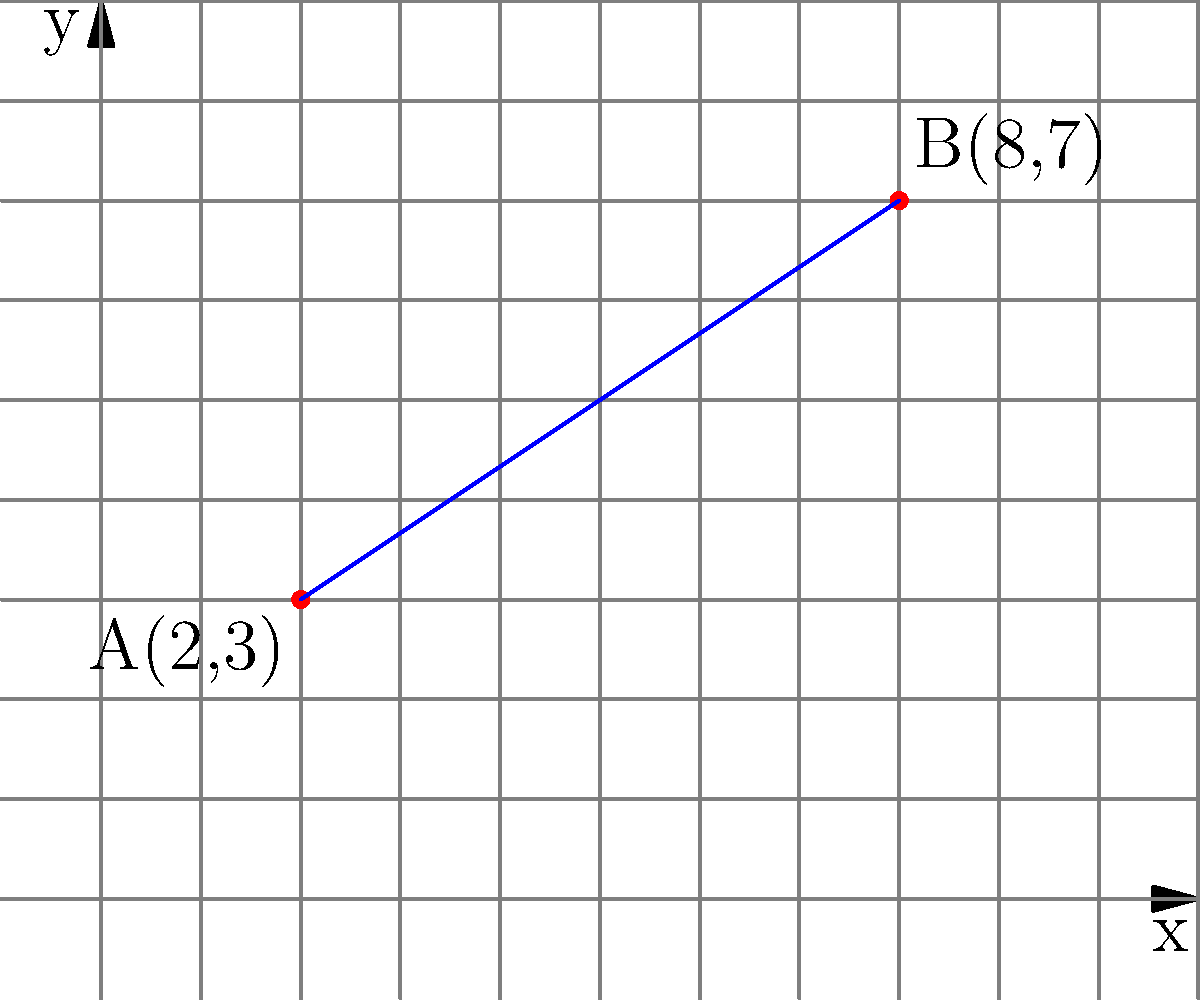No gráfico acima, temos dois pontos A(2,3) e B(8,7) conectados por uma linha reta. Calcule a inclinação (coeficiente angular) desta linha usando a fórmula da inclinação. Apresente sua resposta como uma fração simplificada. Para calcular a inclinação de uma linha reta entre dois pontos, usamos a fórmula:

$$ m = \frac{y_2 - y_1}{x_2 - x_1} $$

Onde $(x_1, y_1)$ são as coordenadas do primeiro ponto e $(x_2, y_2)$ são as coordenadas do segundo ponto.

Neste caso, temos:
A(2,3) como $(x_1, y_1)$ e B(8,7) como $(x_2, y_2)$

Substituindo na fórmula:

$$ m = \frac{7 - 3}{8 - 2} $$

$$ m = \frac{4}{6} $$

Simplificando a fração:

$$ m = \frac{2}{3} $$

Portanto, a inclinação da linha é $\frac{2}{3}$.
Answer: $\frac{2}{3}$ 